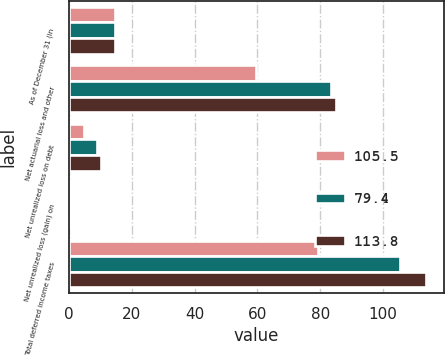<chart> <loc_0><loc_0><loc_500><loc_500><stacked_bar_chart><ecel><fcel>As of December 31 (in<fcel>Net actuarial loss and other<fcel>Net unrealized loss on debt<fcel>Net unrealized loss (gain) on<fcel>Total deferred income taxes<nl><fcel>105.5<fcel>14.7<fcel>59.4<fcel>4.7<fcel>0.6<fcel>79.4<nl><fcel>79.4<fcel>14.7<fcel>83.5<fcel>8.8<fcel>0.5<fcel>105.5<nl><fcel>113.8<fcel>14.7<fcel>85<fcel>10.2<fcel>0.2<fcel>113.8<nl></chart> 